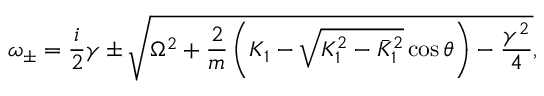<formula> <loc_0><loc_0><loc_500><loc_500>\omega _ { \pm } = \frac { i } { 2 } \gamma \pm \sqrt { \Omega ^ { 2 } + \frac { 2 } { m } \left ( K _ { 1 } - \sqrt { K _ { 1 } ^ { 2 } - \bar { K } _ { 1 } ^ { 2 } } \cos \theta \right ) - \frac { \gamma ^ { 2 } } { 4 } } ,</formula> 